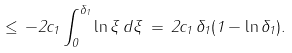Convert formula to latex. <formula><loc_0><loc_0><loc_500><loc_500>\leq \, - 2 c _ { 1 } \int _ { 0 } ^ { \delta _ { 1 } } \ln \xi \, d \xi \, = \, 2 c _ { 1 } \, \delta _ { 1 } ( 1 - \ln \delta _ { 1 } ) .</formula> 